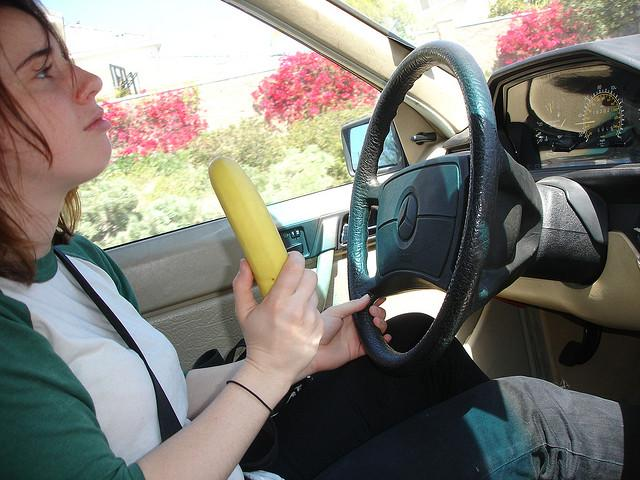Where do bananas originally come from?

Choices:
A) americas
B) asia
C) india
D) france asia 